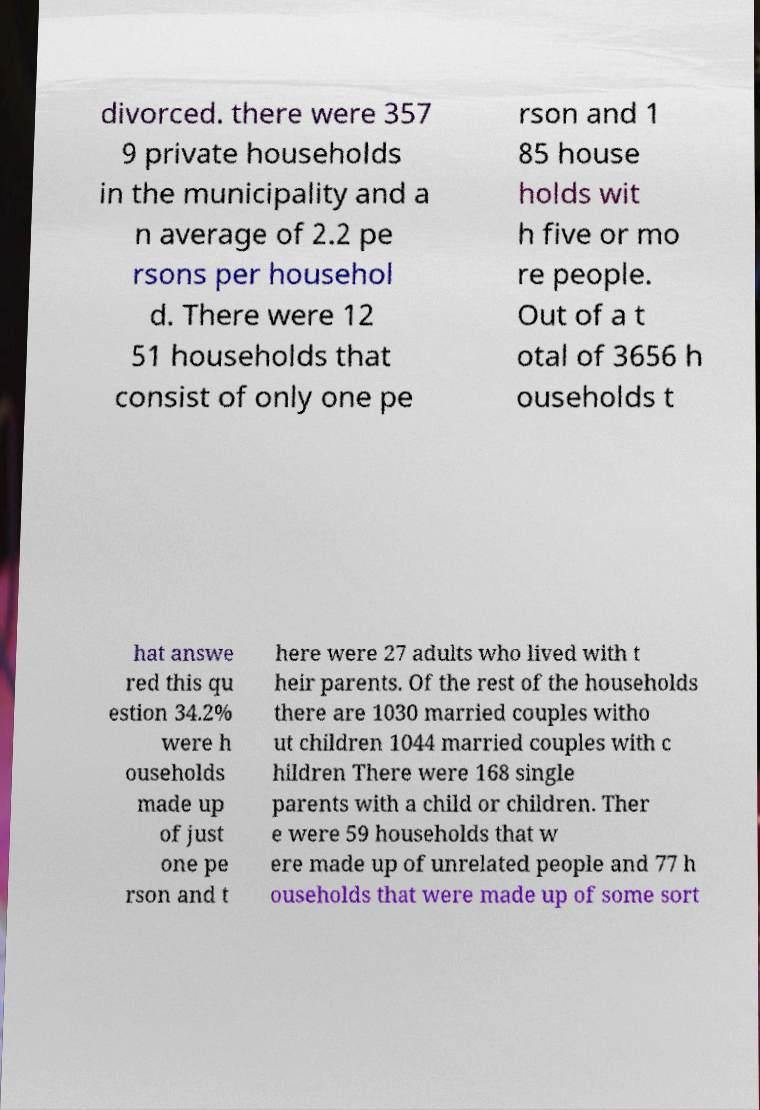Please read and relay the text visible in this image. What does it say? divorced. there were 357 9 private households in the municipality and a n average of 2.2 pe rsons per househol d. There were 12 51 households that consist of only one pe rson and 1 85 house holds wit h five or mo re people. Out of a t otal of 3656 h ouseholds t hat answe red this qu estion 34.2% were h ouseholds made up of just one pe rson and t here were 27 adults who lived with t heir parents. Of the rest of the households there are 1030 married couples witho ut children 1044 married couples with c hildren There were 168 single parents with a child or children. Ther e were 59 households that w ere made up of unrelated people and 77 h ouseholds that were made up of some sort 